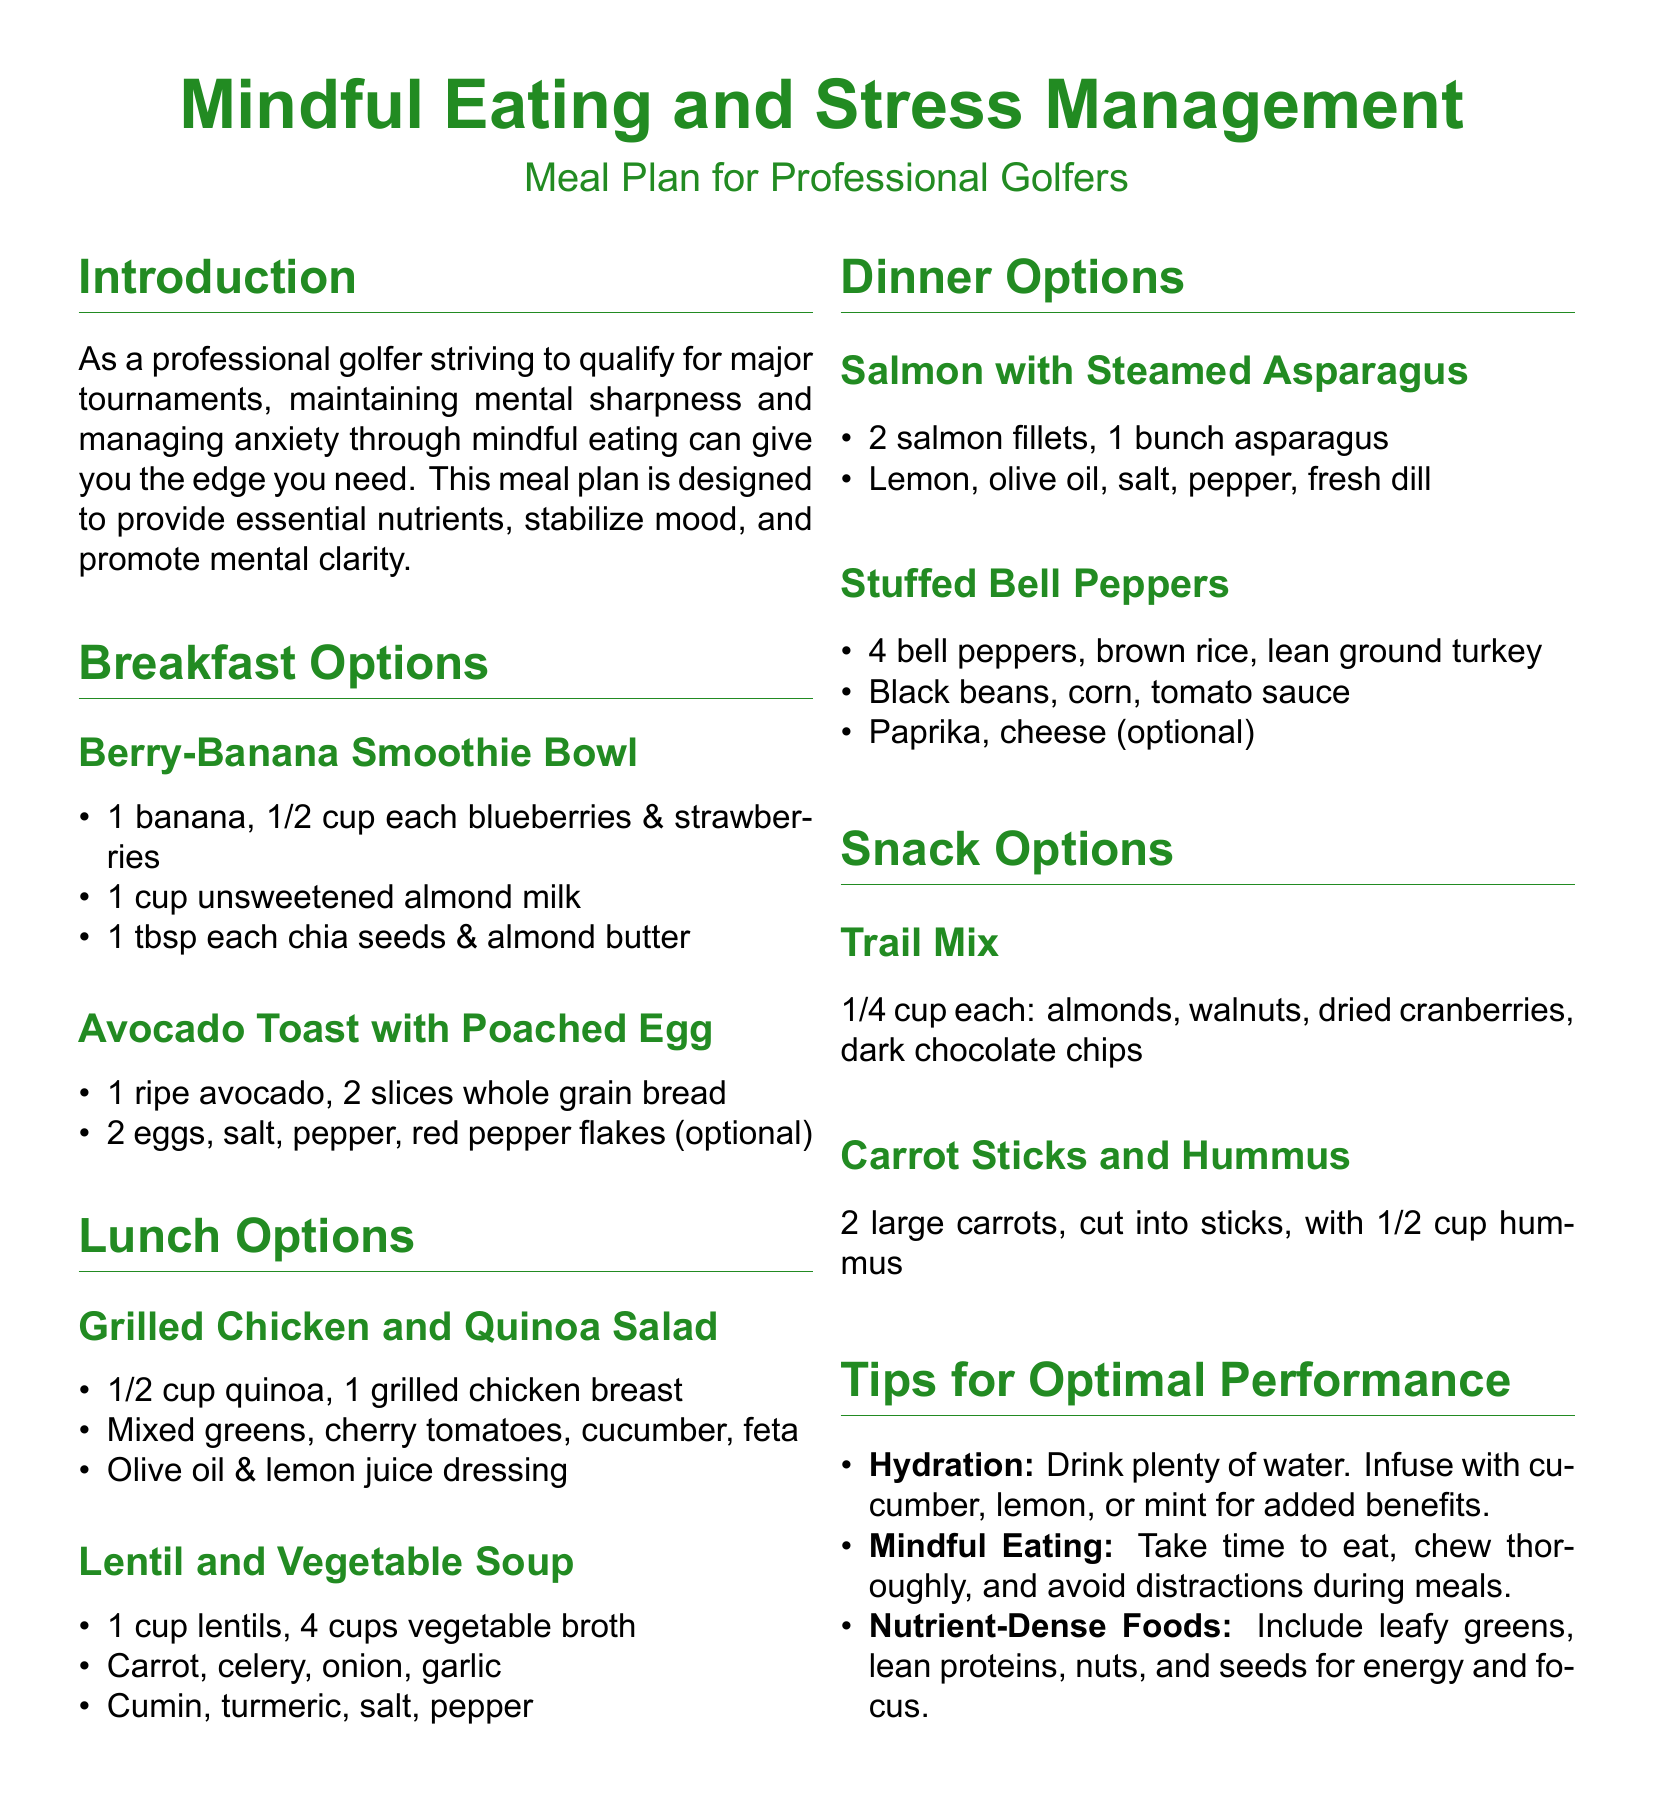what is the title of the document? The title of the document is the main heading, designed to grab the reader's attention.
Answer: Mindful Eating and Stress Management how many breakfast options are listed? The document provides a list of breakfast options under the specific section for meals.
Answer: 2 what ingredient is common in the snack options? The snack options section contains items that can be easily identified and contain specific common ingredients.
Answer: Nuts which dinner option includes vegetables? The options for dinner will often contain various ingredients, including vegetables listed explicitly.
Answer: Stuffed Bell Peppers what type of dressing is used in the Grilled Chicken and Quinoa Salad? The dressing for the salad is specified and described in the lunch options section.
Answer: Olive oil & lemon juice dressing how many cups of vegetable broth are required for the lentil soup? The required amount for the soup is stated directly in the ingredients list for that dish.
Answer: 4 cups what is advised for hydration? This advice appears in the tips section, mentioning beneficial practices related to hydration specifically.
Answer: Drink plenty of water which breakfast option includes eggs? Eggs are mentioned as part of the ingredients in the breakfast options section.
Answer: Avocado Toast with Poached Egg name a nutrient-dense food recommended in the tips for optimal performance. The document lists types of foods to include, focusing on those that enhance performance and mental clarity.
Answer: Leafy greens 